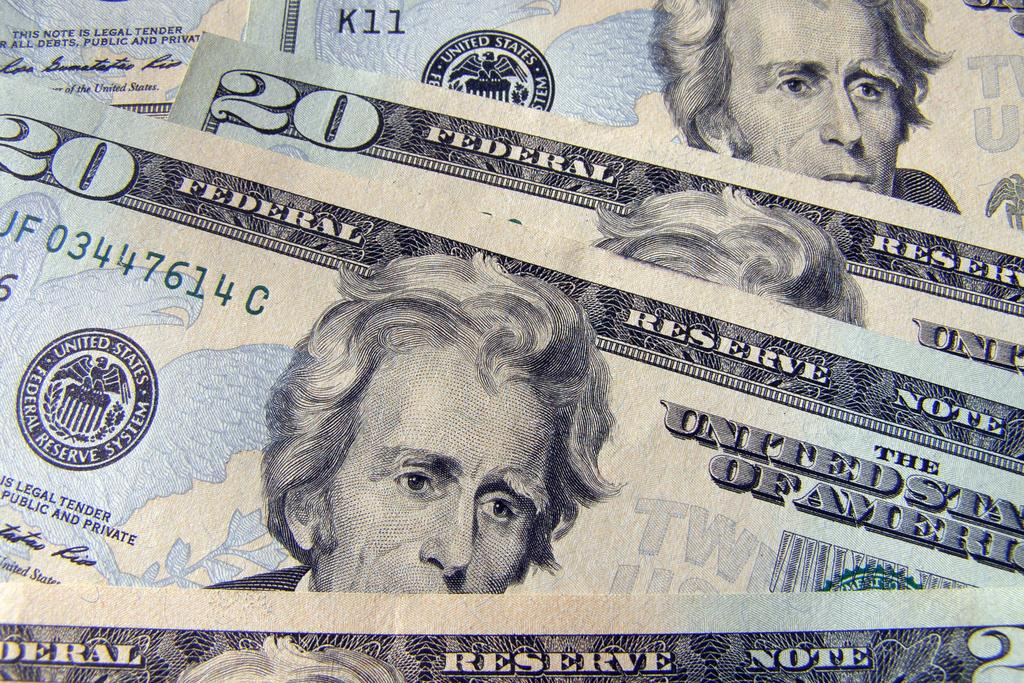What type of currency can be seen in the image? There are dollar notes visible in the image. What type of flooring is visible in the image? The provided facts do not mention any flooring in the image, so it cannot be determined from the information given. 